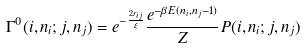Convert formula to latex. <formula><loc_0><loc_0><loc_500><loc_500>\Gamma ^ { 0 } ( i , n _ { i } ; j , n _ { j } ) = e ^ { - \frac { 2 r _ { i j } } { \xi } } \frac { e ^ { - \beta E ( n _ { i } , n _ { j } - 1 ) } } { Z } P ( i , n _ { i } ; j , n _ { j } )</formula> 